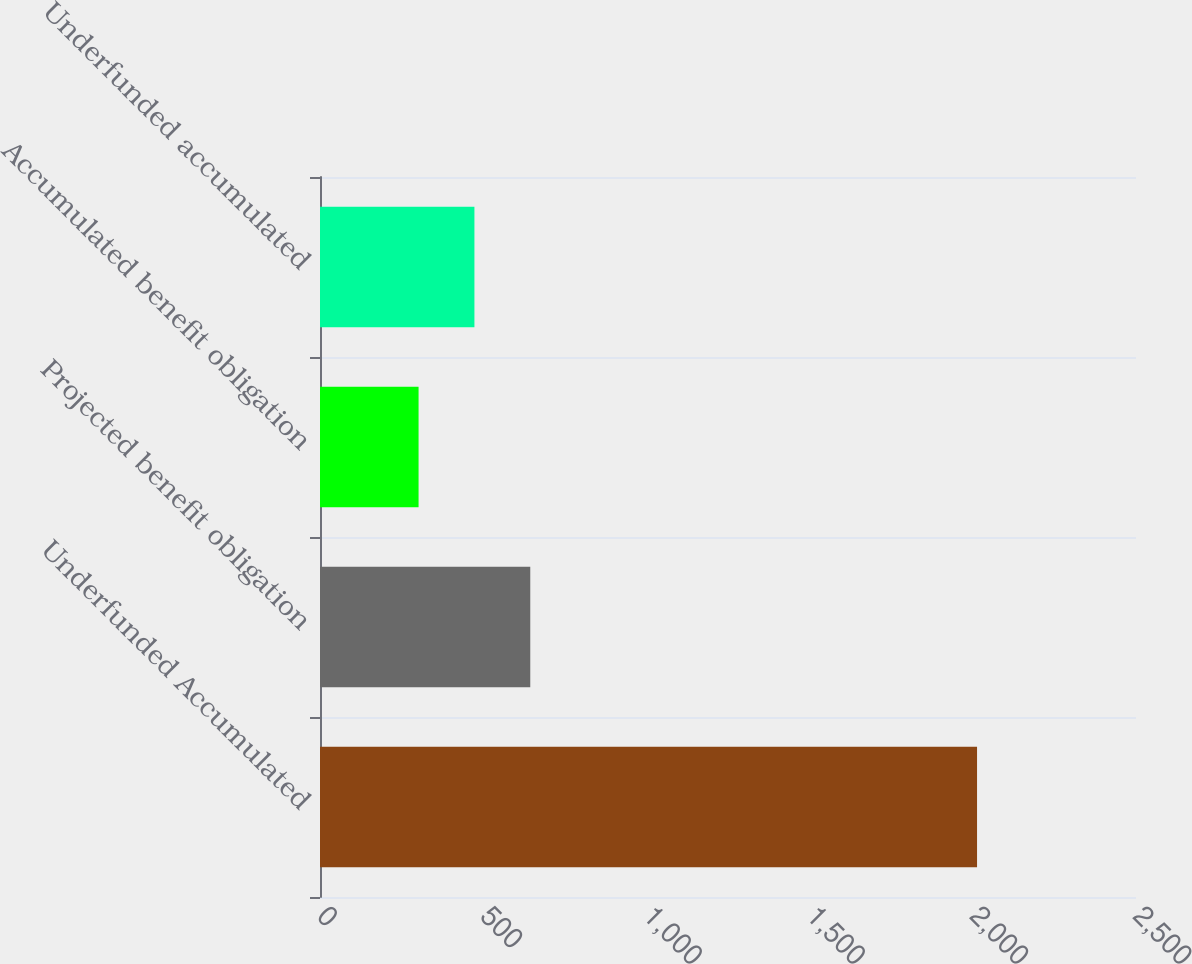Convert chart to OTSL. <chart><loc_0><loc_0><loc_500><loc_500><bar_chart><fcel>Underfunded Accumulated<fcel>Projected benefit obligation<fcel>Accumulated benefit obligation<fcel>Underfunded accumulated<nl><fcel>2013<fcel>644.2<fcel>302<fcel>473.1<nl></chart> 